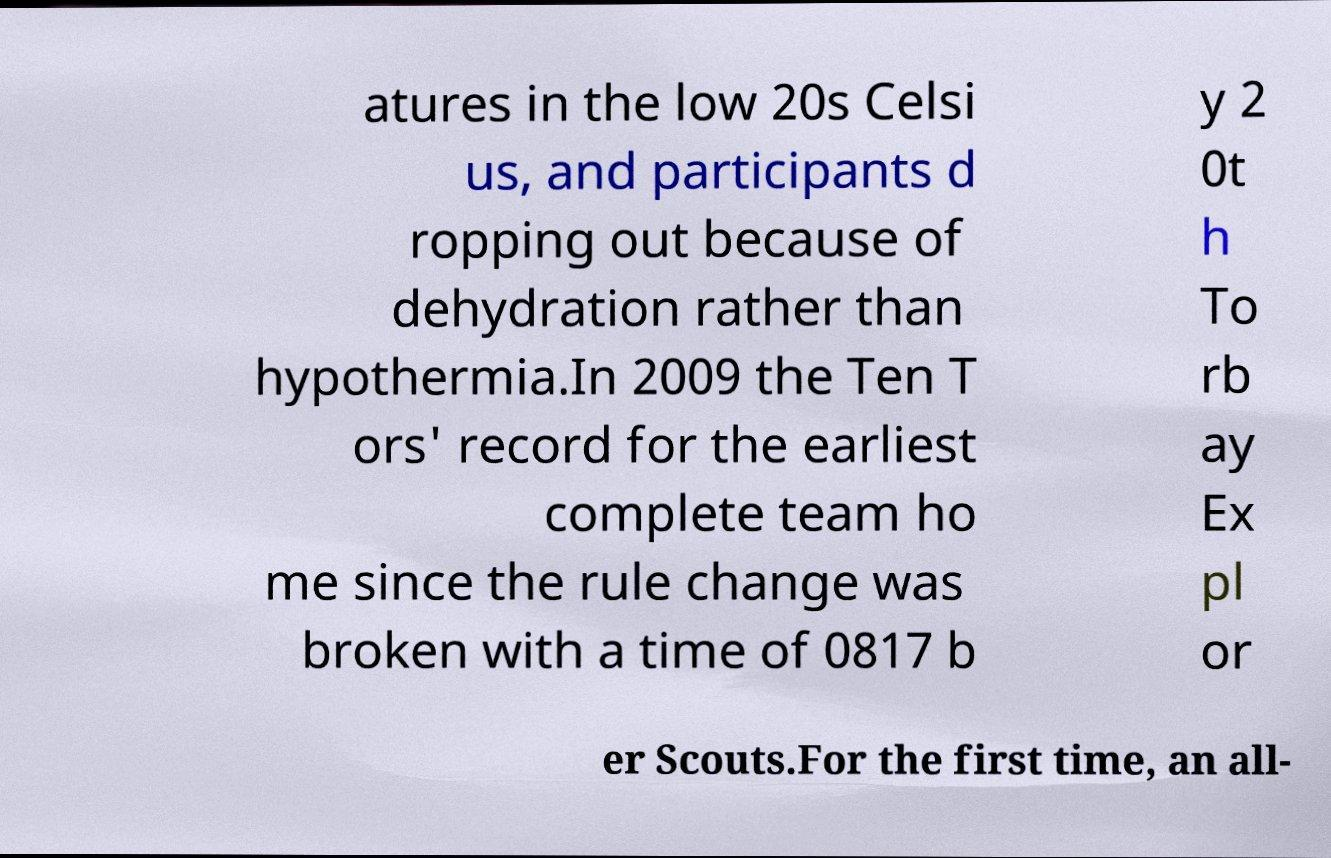For documentation purposes, I need the text within this image transcribed. Could you provide that? atures in the low 20s Celsi us, and participants d ropping out because of dehydration rather than hypothermia.In 2009 the Ten T ors' record for the earliest complete team ho me since the rule change was broken with a time of 0817 b y 2 0t h To rb ay Ex pl or er Scouts.For the first time, an all- 